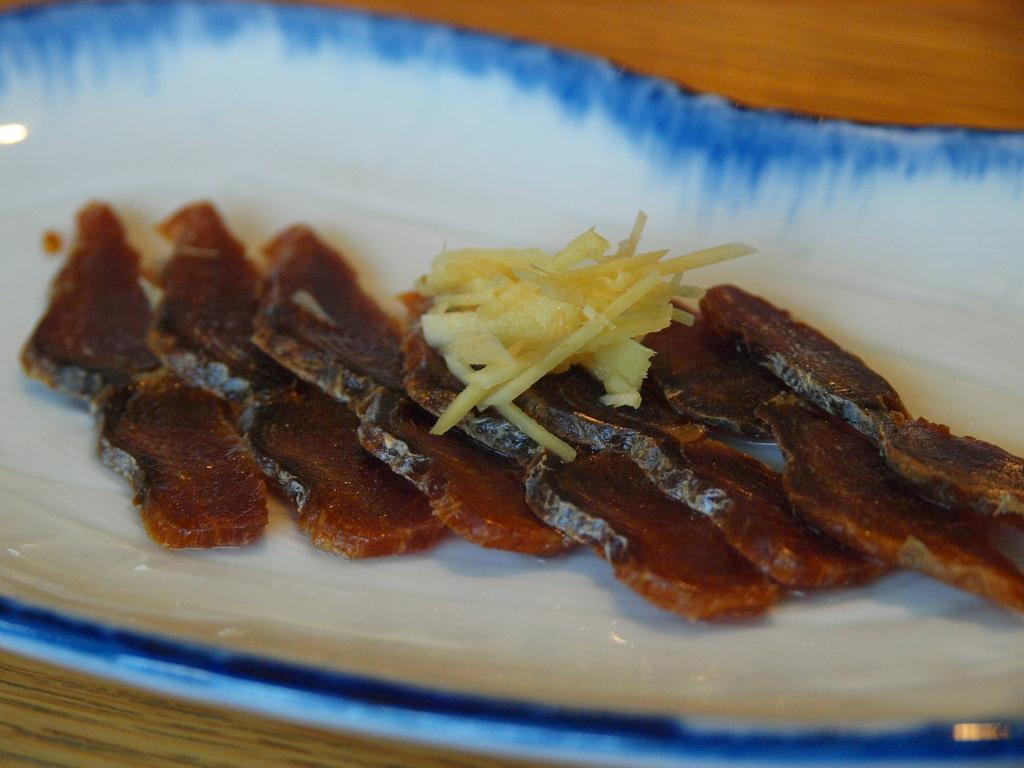What is on the plate that is visible in the image? There is food on a plate in the image, specifically cheese. Where is the plate located in the image? The plate is placed on a table. What type of scissors can be seen cutting the cheese in the image? There are no scissors present in the image, and the cheese is not being cut. 